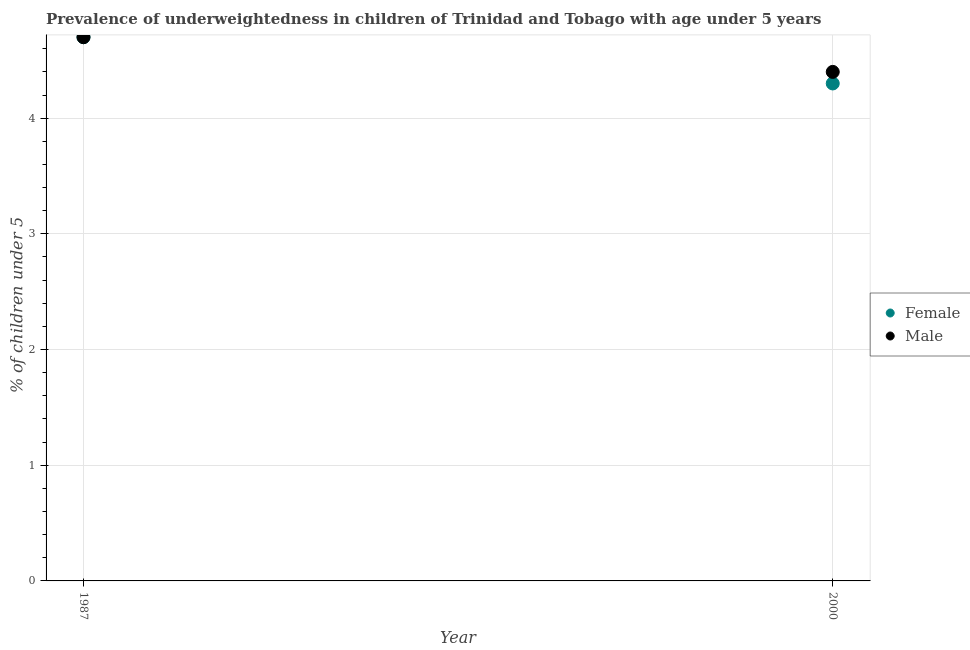How many different coloured dotlines are there?
Your response must be concise. 2. Is the number of dotlines equal to the number of legend labels?
Your response must be concise. Yes. What is the percentage of underweighted female children in 2000?
Your response must be concise. 4.3. Across all years, what is the maximum percentage of underweighted female children?
Your answer should be compact. 4.7. Across all years, what is the minimum percentage of underweighted male children?
Offer a terse response. 4.4. What is the total percentage of underweighted male children in the graph?
Offer a very short reply. 9.1. What is the difference between the percentage of underweighted male children in 1987 and that in 2000?
Make the answer very short. 0.3. What is the difference between the percentage of underweighted male children in 1987 and the percentage of underweighted female children in 2000?
Offer a terse response. 0.4. What is the average percentage of underweighted male children per year?
Your response must be concise. 4.55. In the year 2000, what is the difference between the percentage of underweighted female children and percentage of underweighted male children?
Your answer should be very brief. -0.1. What is the ratio of the percentage of underweighted female children in 1987 to that in 2000?
Your response must be concise. 1.09. Is the percentage of underweighted female children in 1987 less than that in 2000?
Keep it short and to the point. No. In how many years, is the percentage of underweighted female children greater than the average percentage of underweighted female children taken over all years?
Ensure brevity in your answer.  1. Is the percentage of underweighted female children strictly greater than the percentage of underweighted male children over the years?
Your answer should be very brief. No. Is the percentage of underweighted male children strictly less than the percentage of underweighted female children over the years?
Provide a succinct answer. No. How many dotlines are there?
Give a very brief answer. 2. Does the graph contain grids?
Provide a short and direct response. Yes. How are the legend labels stacked?
Your answer should be very brief. Vertical. What is the title of the graph?
Provide a short and direct response. Prevalence of underweightedness in children of Trinidad and Tobago with age under 5 years. Does "Male" appear as one of the legend labels in the graph?
Provide a succinct answer. Yes. What is the label or title of the Y-axis?
Your answer should be very brief.  % of children under 5. What is the  % of children under 5 in Female in 1987?
Keep it short and to the point. 4.7. What is the  % of children under 5 of Male in 1987?
Provide a succinct answer. 4.7. What is the  % of children under 5 in Female in 2000?
Provide a succinct answer. 4.3. What is the  % of children under 5 of Male in 2000?
Ensure brevity in your answer.  4.4. Across all years, what is the maximum  % of children under 5 in Female?
Provide a short and direct response. 4.7. Across all years, what is the maximum  % of children under 5 of Male?
Keep it short and to the point. 4.7. Across all years, what is the minimum  % of children under 5 of Female?
Your answer should be very brief. 4.3. Across all years, what is the minimum  % of children under 5 of Male?
Ensure brevity in your answer.  4.4. What is the total  % of children under 5 of Female in the graph?
Your response must be concise. 9. What is the total  % of children under 5 of Male in the graph?
Provide a succinct answer. 9.1. What is the difference between the  % of children under 5 in Female in 1987 and that in 2000?
Your response must be concise. 0.4. What is the average  % of children under 5 of Female per year?
Your response must be concise. 4.5. What is the average  % of children under 5 in Male per year?
Ensure brevity in your answer.  4.55. In the year 1987, what is the difference between the  % of children under 5 in Female and  % of children under 5 in Male?
Provide a succinct answer. 0. In the year 2000, what is the difference between the  % of children under 5 in Female and  % of children under 5 in Male?
Provide a succinct answer. -0.1. What is the ratio of the  % of children under 5 in Female in 1987 to that in 2000?
Offer a terse response. 1.09. What is the ratio of the  % of children under 5 of Male in 1987 to that in 2000?
Your response must be concise. 1.07. What is the difference between the highest and the second highest  % of children under 5 in Female?
Offer a very short reply. 0.4. What is the difference between the highest and the second highest  % of children under 5 in Male?
Give a very brief answer. 0.3. What is the difference between the highest and the lowest  % of children under 5 of Male?
Your answer should be compact. 0.3. 